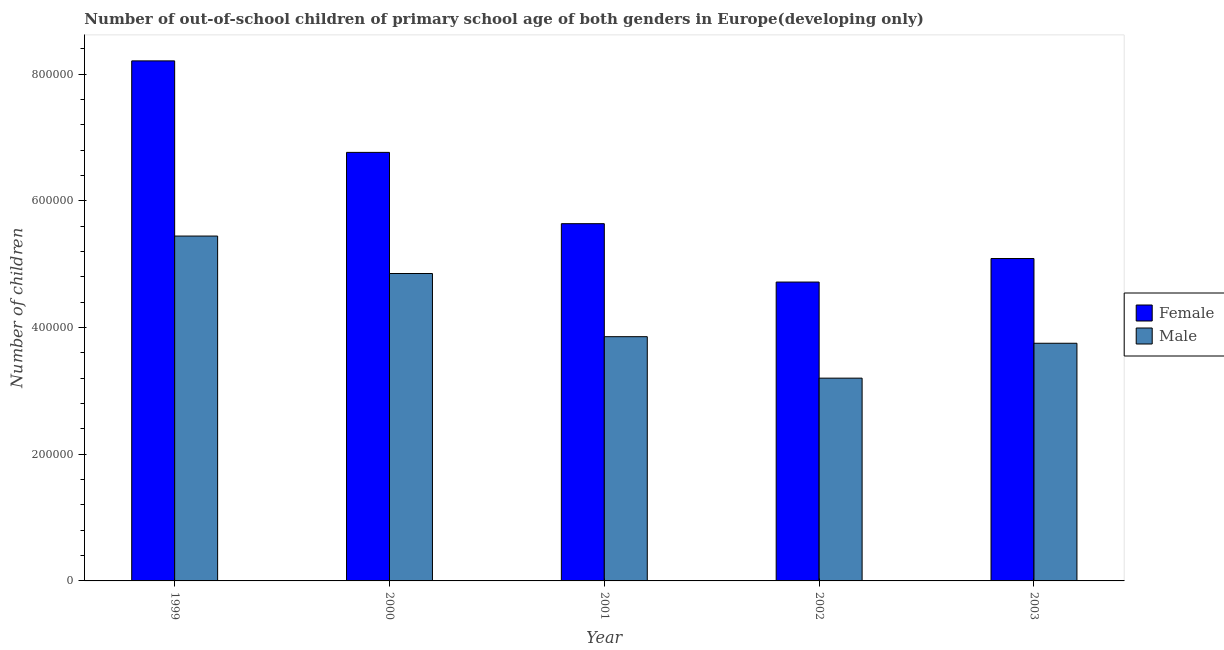Are the number of bars on each tick of the X-axis equal?
Keep it short and to the point. Yes. In how many cases, is the number of bars for a given year not equal to the number of legend labels?
Give a very brief answer. 0. What is the number of female out-of-school students in 2000?
Provide a short and direct response. 6.76e+05. Across all years, what is the maximum number of male out-of-school students?
Your response must be concise. 5.44e+05. Across all years, what is the minimum number of female out-of-school students?
Ensure brevity in your answer.  4.72e+05. What is the total number of female out-of-school students in the graph?
Your answer should be very brief. 3.04e+06. What is the difference between the number of male out-of-school students in 1999 and that in 2000?
Provide a short and direct response. 5.91e+04. What is the difference between the number of female out-of-school students in 2000 and the number of male out-of-school students in 1999?
Keep it short and to the point. -1.44e+05. What is the average number of male out-of-school students per year?
Give a very brief answer. 4.22e+05. In how many years, is the number of male out-of-school students greater than 680000?
Ensure brevity in your answer.  0. What is the ratio of the number of male out-of-school students in 2001 to that in 2003?
Your response must be concise. 1.03. Is the difference between the number of male out-of-school students in 2000 and 2003 greater than the difference between the number of female out-of-school students in 2000 and 2003?
Your response must be concise. No. What is the difference between the highest and the second highest number of female out-of-school students?
Your response must be concise. 1.44e+05. What is the difference between the highest and the lowest number of female out-of-school students?
Keep it short and to the point. 3.49e+05. In how many years, is the number of female out-of-school students greater than the average number of female out-of-school students taken over all years?
Your answer should be compact. 2. Is the sum of the number of male out-of-school students in 1999 and 2000 greater than the maximum number of female out-of-school students across all years?
Your answer should be very brief. Yes. Are the values on the major ticks of Y-axis written in scientific E-notation?
Make the answer very short. No. What is the title of the graph?
Your response must be concise. Number of out-of-school children of primary school age of both genders in Europe(developing only). Does "By country of origin" appear as one of the legend labels in the graph?
Provide a short and direct response. No. What is the label or title of the X-axis?
Offer a terse response. Year. What is the label or title of the Y-axis?
Make the answer very short. Number of children. What is the Number of children of Female in 1999?
Offer a very short reply. 8.21e+05. What is the Number of children in Male in 1999?
Offer a terse response. 5.44e+05. What is the Number of children of Female in 2000?
Make the answer very short. 6.76e+05. What is the Number of children of Male in 2000?
Your response must be concise. 4.85e+05. What is the Number of children in Female in 2001?
Provide a short and direct response. 5.64e+05. What is the Number of children in Male in 2001?
Offer a terse response. 3.85e+05. What is the Number of children of Female in 2002?
Provide a short and direct response. 4.72e+05. What is the Number of children in Male in 2002?
Provide a succinct answer. 3.20e+05. What is the Number of children in Female in 2003?
Make the answer very short. 5.09e+05. What is the Number of children in Male in 2003?
Provide a short and direct response. 3.75e+05. Across all years, what is the maximum Number of children in Female?
Offer a terse response. 8.21e+05. Across all years, what is the maximum Number of children of Male?
Your response must be concise. 5.44e+05. Across all years, what is the minimum Number of children in Female?
Provide a succinct answer. 4.72e+05. Across all years, what is the minimum Number of children in Male?
Offer a very short reply. 3.20e+05. What is the total Number of children in Female in the graph?
Give a very brief answer. 3.04e+06. What is the total Number of children in Male in the graph?
Give a very brief answer. 2.11e+06. What is the difference between the Number of children of Female in 1999 and that in 2000?
Offer a terse response. 1.44e+05. What is the difference between the Number of children of Male in 1999 and that in 2000?
Your answer should be very brief. 5.91e+04. What is the difference between the Number of children of Female in 1999 and that in 2001?
Keep it short and to the point. 2.57e+05. What is the difference between the Number of children of Male in 1999 and that in 2001?
Your answer should be very brief. 1.59e+05. What is the difference between the Number of children of Female in 1999 and that in 2002?
Your response must be concise. 3.49e+05. What is the difference between the Number of children of Male in 1999 and that in 2002?
Your answer should be compact. 2.24e+05. What is the difference between the Number of children in Female in 1999 and that in 2003?
Your answer should be very brief. 3.12e+05. What is the difference between the Number of children of Male in 1999 and that in 2003?
Your answer should be compact. 1.69e+05. What is the difference between the Number of children in Female in 2000 and that in 2001?
Make the answer very short. 1.13e+05. What is the difference between the Number of children in Male in 2000 and that in 2001?
Your answer should be compact. 9.97e+04. What is the difference between the Number of children in Female in 2000 and that in 2002?
Provide a short and direct response. 2.05e+05. What is the difference between the Number of children of Male in 2000 and that in 2002?
Make the answer very short. 1.65e+05. What is the difference between the Number of children of Female in 2000 and that in 2003?
Offer a terse response. 1.68e+05. What is the difference between the Number of children in Male in 2000 and that in 2003?
Offer a very short reply. 1.10e+05. What is the difference between the Number of children of Female in 2001 and that in 2002?
Your answer should be compact. 9.21e+04. What is the difference between the Number of children of Male in 2001 and that in 2002?
Your answer should be very brief. 6.54e+04. What is the difference between the Number of children of Female in 2001 and that in 2003?
Your answer should be compact. 5.50e+04. What is the difference between the Number of children in Male in 2001 and that in 2003?
Offer a terse response. 1.04e+04. What is the difference between the Number of children in Female in 2002 and that in 2003?
Give a very brief answer. -3.71e+04. What is the difference between the Number of children in Male in 2002 and that in 2003?
Ensure brevity in your answer.  -5.51e+04. What is the difference between the Number of children in Female in 1999 and the Number of children in Male in 2000?
Make the answer very short. 3.36e+05. What is the difference between the Number of children of Female in 1999 and the Number of children of Male in 2001?
Provide a short and direct response. 4.35e+05. What is the difference between the Number of children of Female in 1999 and the Number of children of Male in 2002?
Ensure brevity in your answer.  5.01e+05. What is the difference between the Number of children of Female in 1999 and the Number of children of Male in 2003?
Offer a terse response. 4.46e+05. What is the difference between the Number of children in Female in 2000 and the Number of children in Male in 2001?
Your response must be concise. 2.91e+05. What is the difference between the Number of children of Female in 2000 and the Number of children of Male in 2002?
Your answer should be compact. 3.56e+05. What is the difference between the Number of children in Female in 2000 and the Number of children in Male in 2003?
Your response must be concise. 3.01e+05. What is the difference between the Number of children of Female in 2001 and the Number of children of Male in 2002?
Give a very brief answer. 2.44e+05. What is the difference between the Number of children in Female in 2001 and the Number of children in Male in 2003?
Provide a short and direct response. 1.89e+05. What is the difference between the Number of children in Female in 2002 and the Number of children in Male in 2003?
Your answer should be very brief. 9.66e+04. What is the average Number of children of Female per year?
Offer a terse response. 6.08e+05. What is the average Number of children in Male per year?
Offer a very short reply. 4.22e+05. In the year 1999, what is the difference between the Number of children in Female and Number of children in Male?
Give a very brief answer. 2.76e+05. In the year 2000, what is the difference between the Number of children of Female and Number of children of Male?
Provide a short and direct response. 1.91e+05. In the year 2001, what is the difference between the Number of children of Female and Number of children of Male?
Offer a very short reply. 1.78e+05. In the year 2002, what is the difference between the Number of children of Female and Number of children of Male?
Provide a succinct answer. 1.52e+05. In the year 2003, what is the difference between the Number of children of Female and Number of children of Male?
Your response must be concise. 1.34e+05. What is the ratio of the Number of children of Female in 1999 to that in 2000?
Make the answer very short. 1.21. What is the ratio of the Number of children in Male in 1999 to that in 2000?
Your response must be concise. 1.12. What is the ratio of the Number of children in Female in 1999 to that in 2001?
Ensure brevity in your answer.  1.46. What is the ratio of the Number of children in Male in 1999 to that in 2001?
Keep it short and to the point. 1.41. What is the ratio of the Number of children of Female in 1999 to that in 2002?
Make the answer very short. 1.74. What is the ratio of the Number of children of Male in 1999 to that in 2002?
Offer a terse response. 1.7. What is the ratio of the Number of children of Female in 1999 to that in 2003?
Offer a very short reply. 1.61. What is the ratio of the Number of children in Male in 1999 to that in 2003?
Provide a succinct answer. 1.45. What is the ratio of the Number of children in Female in 2000 to that in 2001?
Ensure brevity in your answer.  1.2. What is the ratio of the Number of children in Male in 2000 to that in 2001?
Offer a very short reply. 1.26. What is the ratio of the Number of children in Female in 2000 to that in 2002?
Your response must be concise. 1.43. What is the ratio of the Number of children of Male in 2000 to that in 2002?
Provide a short and direct response. 1.52. What is the ratio of the Number of children of Female in 2000 to that in 2003?
Make the answer very short. 1.33. What is the ratio of the Number of children of Male in 2000 to that in 2003?
Offer a very short reply. 1.29. What is the ratio of the Number of children of Female in 2001 to that in 2002?
Provide a succinct answer. 1.2. What is the ratio of the Number of children in Male in 2001 to that in 2002?
Ensure brevity in your answer.  1.2. What is the ratio of the Number of children in Female in 2001 to that in 2003?
Keep it short and to the point. 1.11. What is the ratio of the Number of children in Male in 2001 to that in 2003?
Keep it short and to the point. 1.03. What is the ratio of the Number of children in Female in 2002 to that in 2003?
Your answer should be compact. 0.93. What is the ratio of the Number of children of Male in 2002 to that in 2003?
Give a very brief answer. 0.85. What is the difference between the highest and the second highest Number of children in Female?
Ensure brevity in your answer.  1.44e+05. What is the difference between the highest and the second highest Number of children in Male?
Provide a succinct answer. 5.91e+04. What is the difference between the highest and the lowest Number of children of Female?
Ensure brevity in your answer.  3.49e+05. What is the difference between the highest and the lowest Number of children in Male?
Provide a short and direct response. 2.24e+05. 